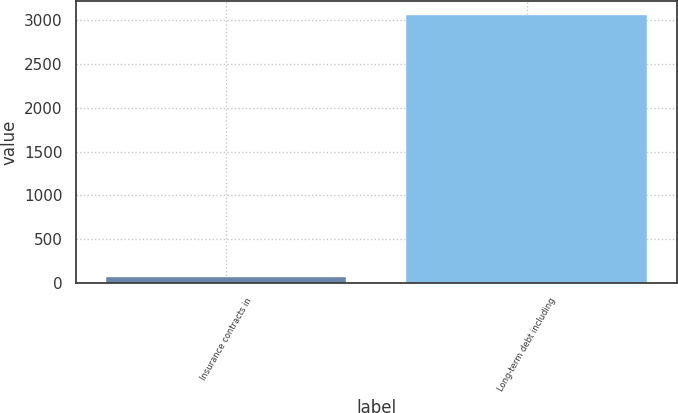<chart> <loc_0><loc_0><loc_500><loc_500><bar_chart><fcel>Insurance contracts in<fcel>Long-term debt including<nl><fcel>70<fcel>3064<nl></chart> 